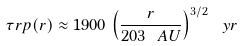Convert formula to latex. <formula><loc_0><loc_0><loc_500><loc_500>\tau r p ( r ) \approx 1 9 0 0 \, \left ( \frac { r } { 2 0 3 \ A U } \right ) ^ { 3 / 2 } \ y r</formula> 